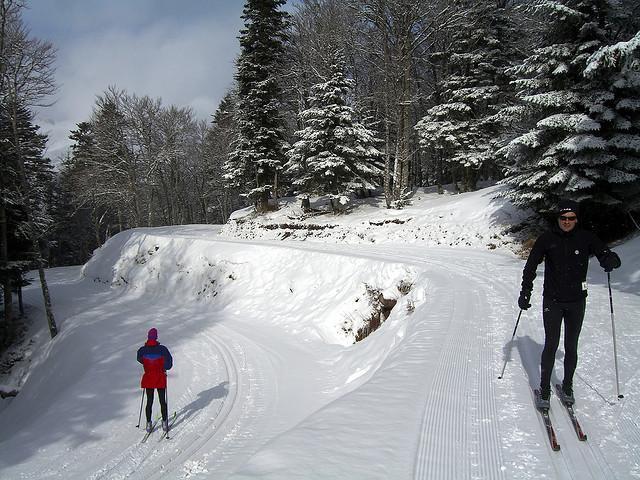How many people are there?
Give a very brief answer. 2. 